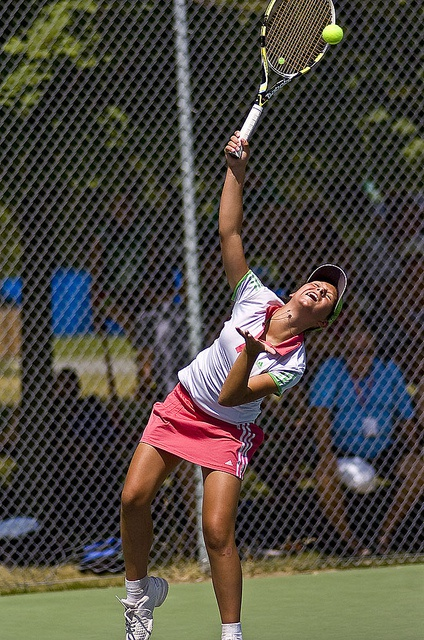Describe the objects in this image and their specific colors. I can see people in darkgreen, black, maroon, lightgray, and gray tones, people in darkgreen, black, gray, navy, and darkblue tones, people in darkgreen, black, gray, and darkgray tones, tennis racket in darkgreen, black, gray, white, and olive tones, and people in darkgreen, black, and gray tones in this image. 